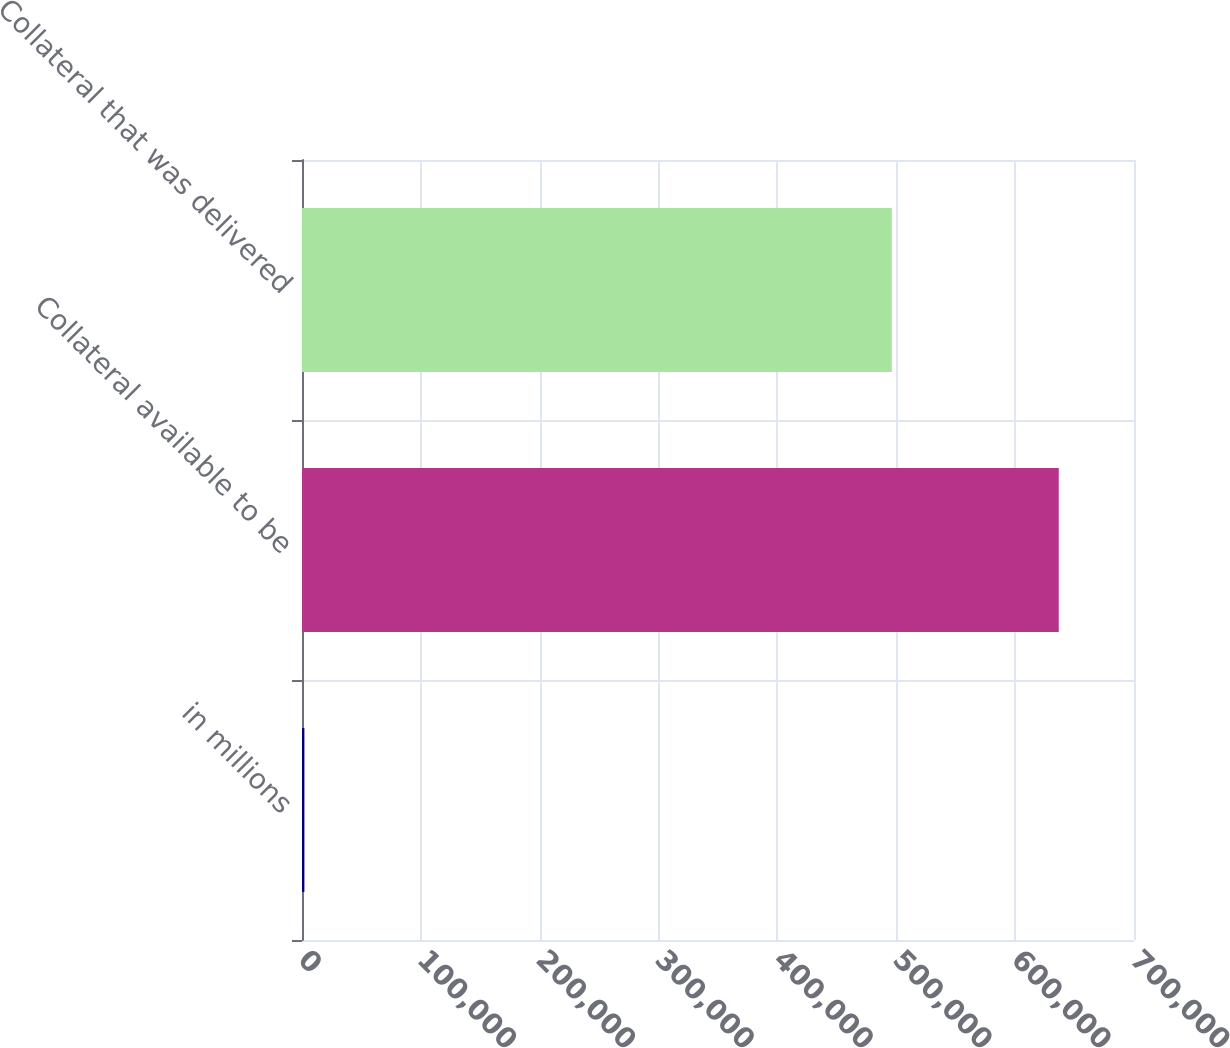Convert chart. <chart><loc_0><loc_0><loc_500><loc_500><bar_chart><fcel>in millions<fcel>Collateral available to be<fcel>Collateral that was delivered<nl><fcel>2015<fcel>636684<fcel>496240<nl></chart> 